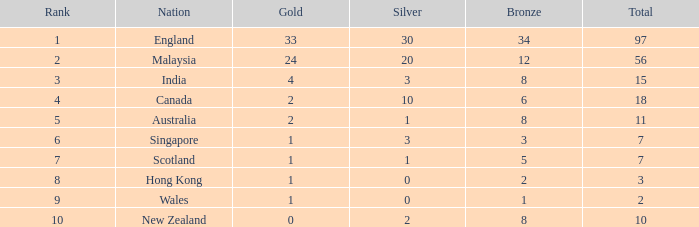What is the highest rank a team with 1 silver and less than 5 bronze medals has? None. 